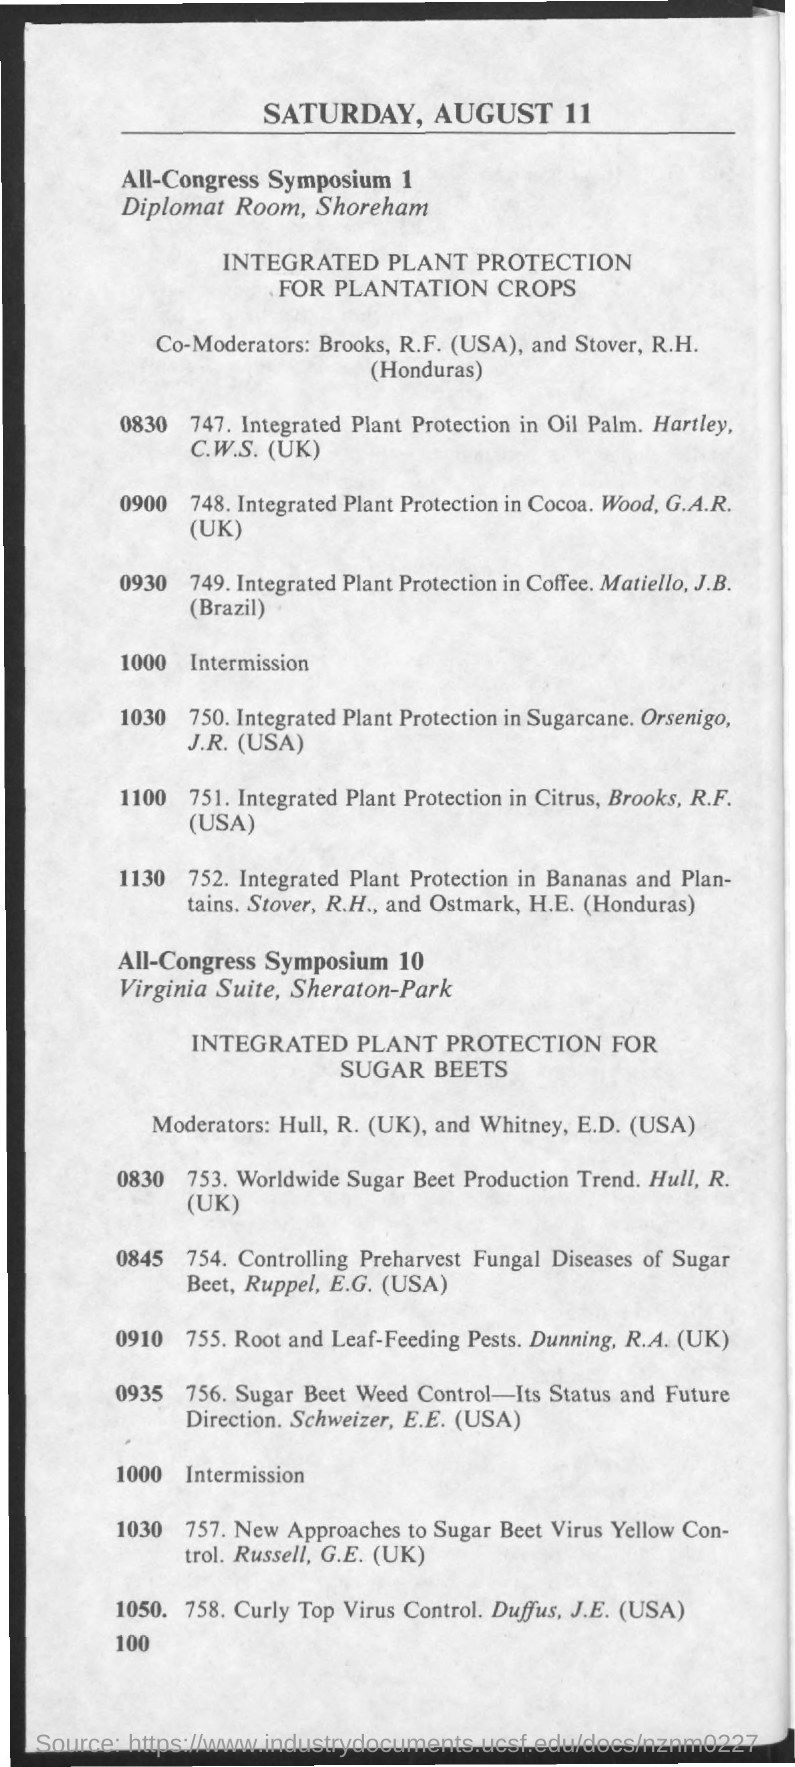Give some essential details in this illustration. The date mentioned in the document is Saturday, August 11. 